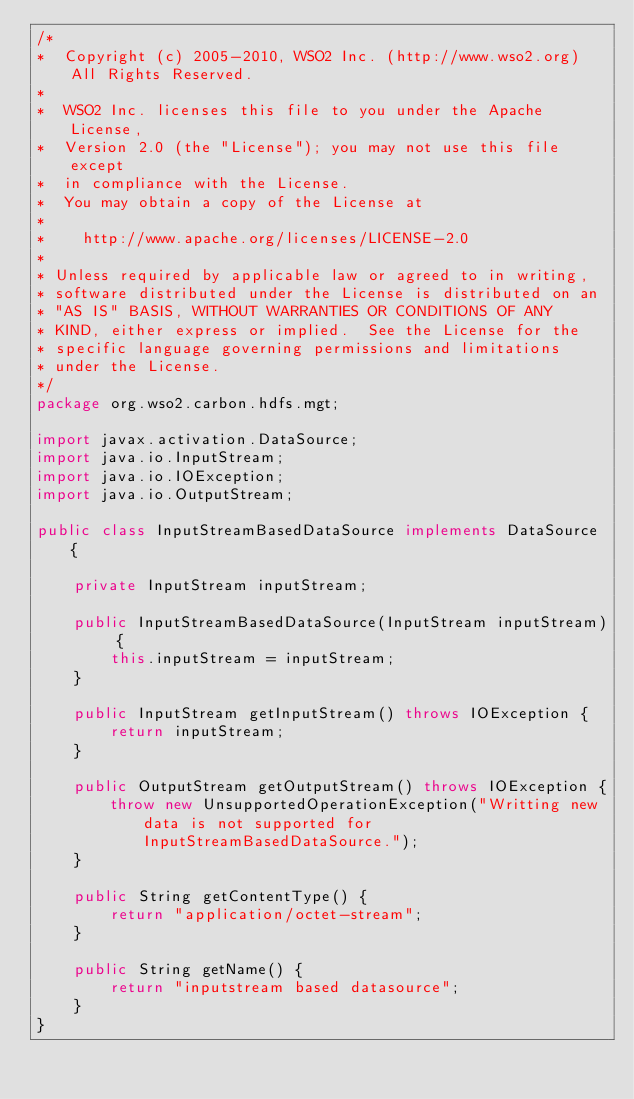<code> <loc_0><loc_0><loc_500><loc_500><_Java_>/*
*  Copyright (c) 2005-2010, WSO2 Inc. (http://www.wso2.org) All Rights Reserved.
*
*  WSO2 Inc. licenses this file to you under the Apache License,
*  Version 2.0 (the "License"); you may not use this file except
*  in compliance with the License.
*  You may obtain a copy of the License at
*
*    http://www.apache.org/licenses/LICENSE-2.0
*
* Unless required by applicable law or agreed to in writing,
* software distributed under the License is distributed on an
* "AS IS" BASIS, WITHOUT WARRANTIES OR CONDITIONS OF ANY
* KIND, either express or implied.  See the License for the
* specific language governing permissions and limitations
* under the License.
*/
package org.wso2.carbon.hdfs.mgt;

import javax.activation.DataSource;
import java.io.InputStream;
import java.io.IOException;
import java.io.OutputStream;

public class InputStreamBasedDataSource implements DataSource {

    private InputStream inputStream;

    public InputStreamBasedDataSource(InputStream inputStream) {
        this.inputStream = inputStream;
    }

    public InputStream getInputStream() throws IOException {
        return inputStream;
    }

    public OutputStream getOutputStream() throws IOException {
        throw new UnsupportedOperationException("Writting new data is not supported for InputStreamBasedDataSource.");
    }

    public String getContentType() {
        return "application/octet-stream";
    }

    public String getName() {
        return "inputstream based datasource";
    }
}
</code> 